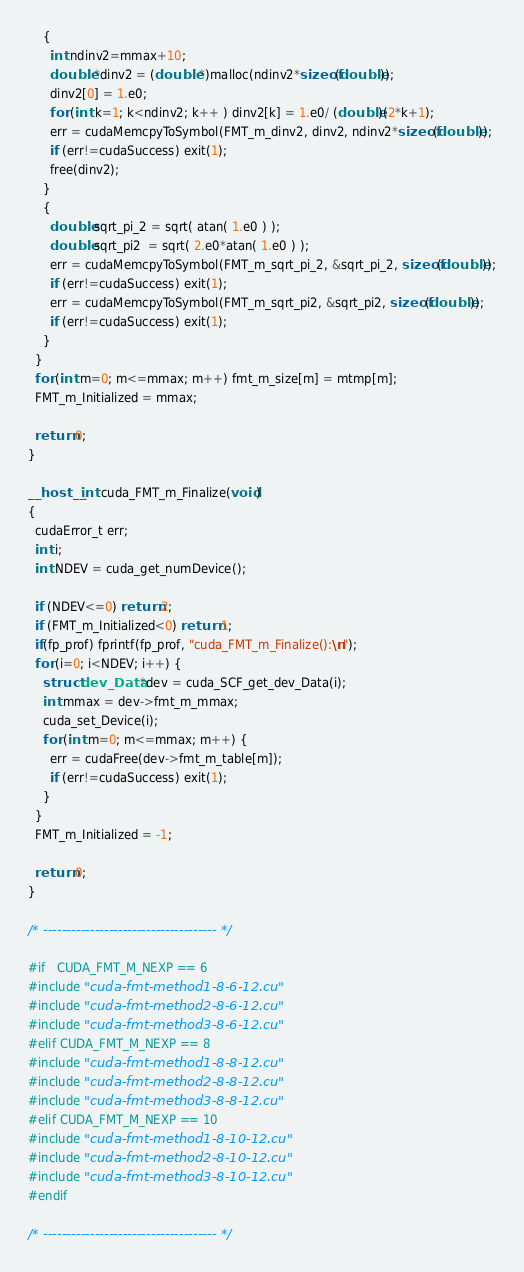<code> <loc_0><loc_0><loc_500><loc_500><_Cuda_>    {
      int ndinv2=mmax+10;
      double *dinv2 = (double *)malloc(ndinv2*sizeof(double));
      dinv2[0] = 1.e0;
      for (int k=1; k<ndinv2; k++ ) dinv2[k] = 1.e0/ (double)(2*k+1);
      err = cudaMemcpyToSymbol(FMT_m_dinv2, dinv2, ndinv2*sizeof(double));
      if (err!=cudaSuccess) exit(1);
      free(dinv2);
    }
    {
      double sqrt_pi_2 = sqrt( atan( 1.e0 ) );
      double sqrt_pi2  = sqrt( 2.e0*atan( 1.e0 ) );
      err = cudaMemcpyToSymbol(FMT_m_sqrt_pi_2, &sqrt_pi_2, sizeof(double));
      if (err!=cudaSuccess) exit(1);
      err = cudaMemcpyToSymbol(FMT_m_sqrt_pi2, &sqrt_pi2, sizeof(double));
      if (err!=cudaSuccess) exit(1);
    }
  }
  for (int m=0; m<=mmax; m++) fmt_m_size[m] = mtmp[m];
  FMT_m_Initialized = mmax;

  return 0;
}

__host__ int cuda_FMT_m_Finalize(void)
{
  cudaError_t err;
  int i;
  int NDEV = cuda_get_numDevice();

  if (NDEV<=0) return 2;
  if (FMT_m_Initialized<0) return 1;
  if(fp_prof) fprintf(fp_prof, "cuda_FMT_m_Finalize():\n");
  for (i=0; i<NDEV; i++) {
    struct dev_Data *dev = cuda_SCF_get_dev_Data(i);
    int mmax = dev->fmt_m_mmax;
    cuda_set_Device(i);
    for (int m=0; m<=mmax; m++) { 
      err = cudaFree(dev->fmt_m_table[m]);
      if (err!=cudaSuccess) exit(1);
    }
  }
  FMT_m_Initialized = -1;

  return 0;
}

/* ------------------------------------- */

#if   CUDA_FMT_M_NEXP == 6
#include "cuda-fmt-method1-8-6-12.cu"
#include "cuda-fmt-method2-8-6-12.cu"
#include "cuda-fmt-method3-8-6-12.cu"
#elif CUDA_FMT_M_NEXP == 8
#include "cuda-fmt-method1-8-8-12.cu"
#include "cuda-fmt-method2-8-8-12.cu"
#include "cuda-fmt-method3-8-8-12.cu"
#elif CUDA_FMT_M_NEXP == 10
#include "cuda-fmt-method1-8-10-12.cu"
#include "cuda-fmt-method2-8-10-12.cu"
#include "cuda-fmt-method3-8-10-12.cu"
#endif

/* ------------------------------------- */

</code> 